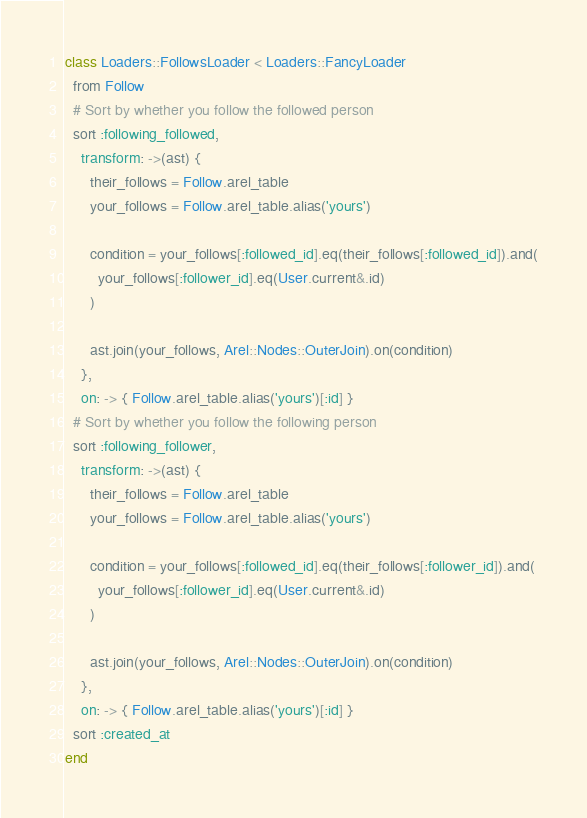<code> <loc_0><loc_0><loc_500><loc_500><_Ruby_>class Loaders::FollowsLoader < Loaders::FancyLoader
  from Follow
  # Sort by whether you follow the followed person
  sort :following_followed,
    transform: ->(ast) {
      their_follows = Follow.arel_table
      your_follows = Follow.arel_table.alias('yours')

      condition = your_follows[:followed_id].eq(their_follows[:followed_id]).and(
        your_follows[:follower_id].eq(User.current&.id)
      )

      ast.join(your_follows, Arel::Nodes::OuterJoin).on(condition)
    },
    on: -> { Follow.arel_table.alias('yours')[:id] }
  # Sort by whether you follow the following person
  sort :following_follower,
    transform: ->(ast) {
      their_follows = Follow.arel_table
      your_follows = Follow.arel_table.alias('yours')

      condition = your_follows[:followed_id].eq(their_follows[:follower_id]).and(
        your_follows[:follower_id].eq(User.current&.id)
      )

      ast.join(your_follows, Arel::Nodes::OuterJoin).on(condition)
    },
    on: -> { Follow.arel_table.alias('yours')[:id] }
  sort :created_at
end
</code> 